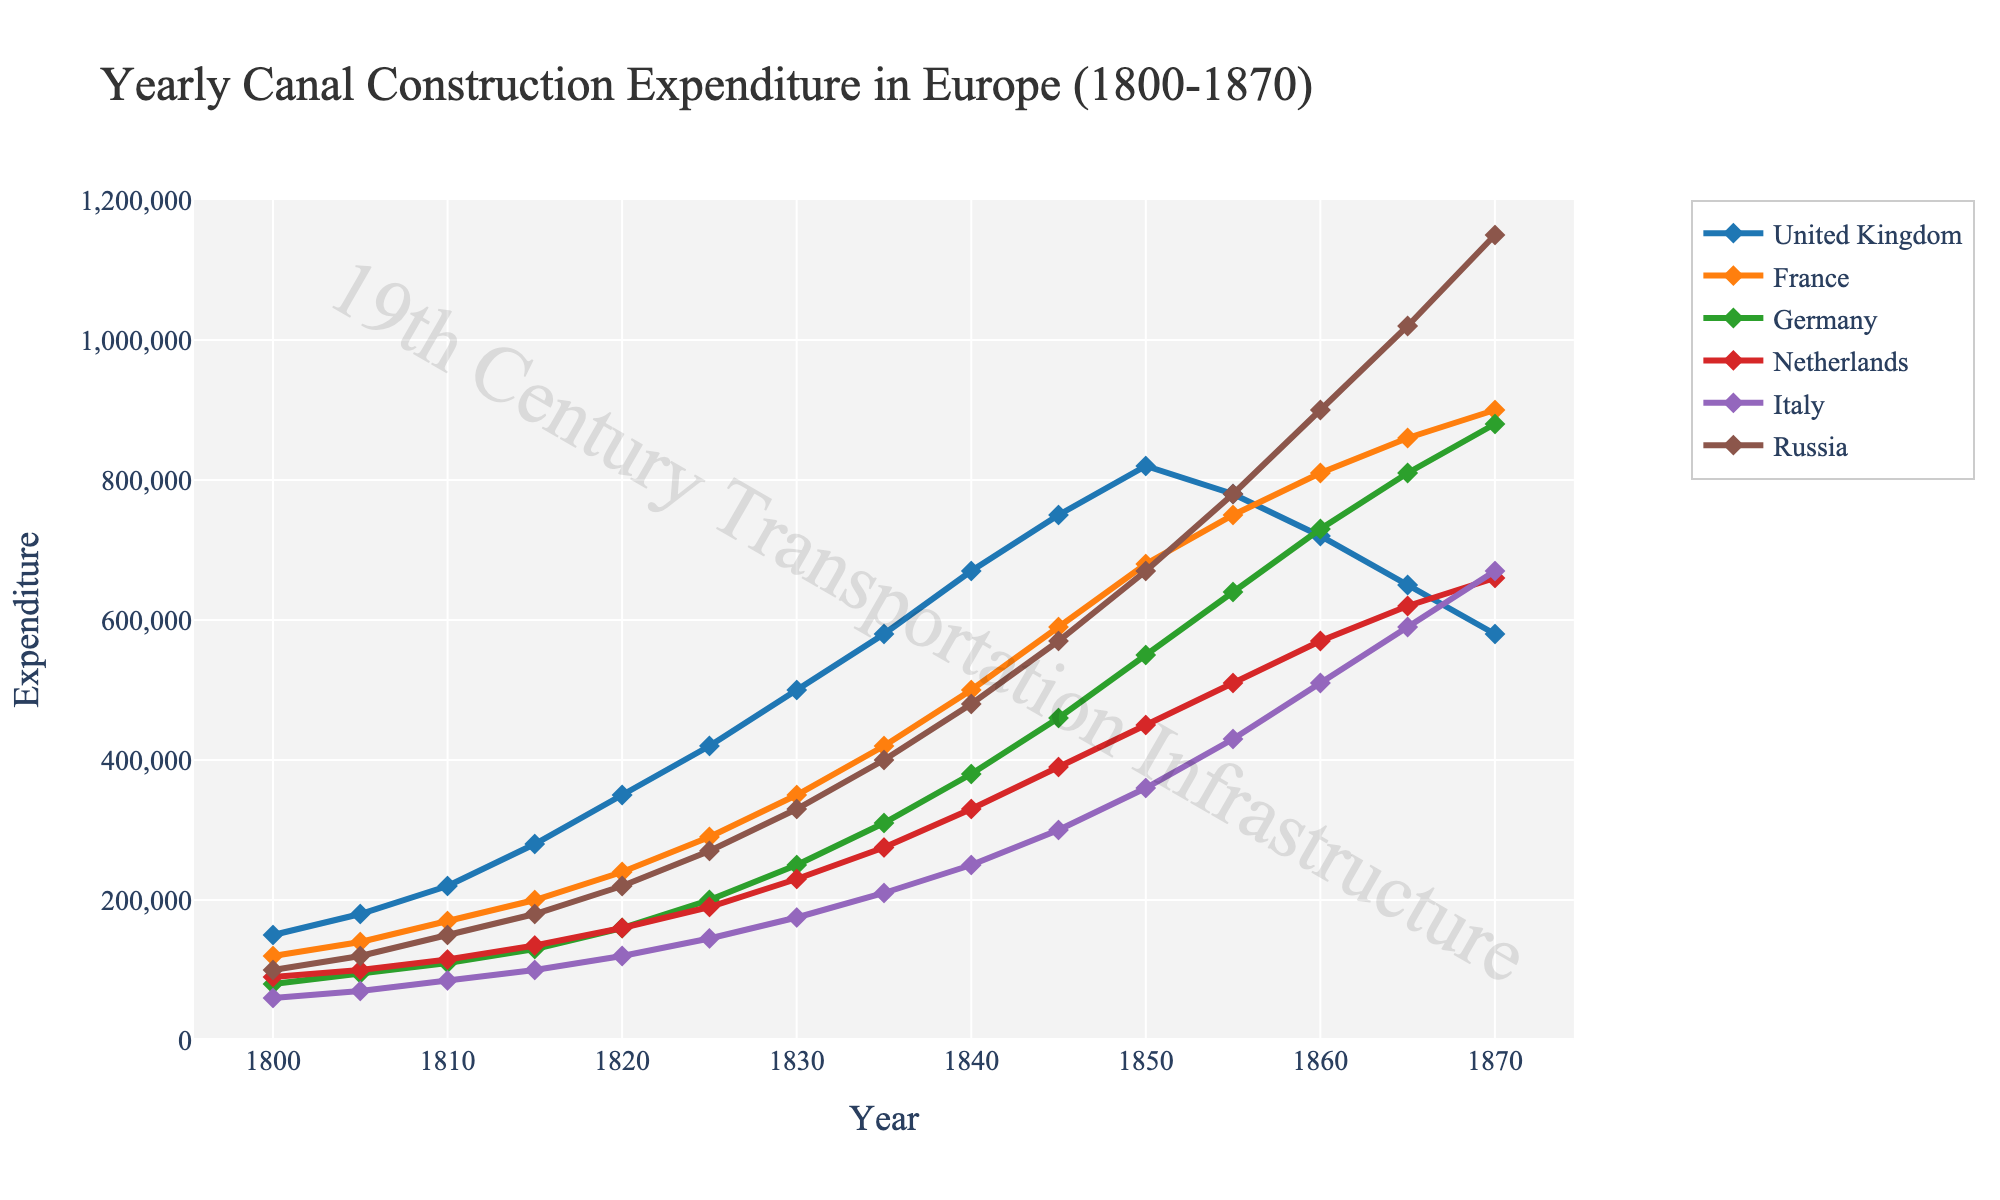what was the expenditure of the United Kingdom and France combined in 1850? To find the combined expenditure of the United Kingdom and France in 1850, sum their individual expenditures. From the data: United Kingdom = 820,000 and France = 680,000. Combined expenditure = 820,000 + 680,000.
Answer: 1,500,000 Which country had the highest canal construction expenditure in 1830? Compare the expenditures of all the countries in 1830. The expenditures are: United Kingdom = 500,000, France = 350,000, Germany = 250,000, Netherlands = 230,000, Italy = 175,000, Russia = 330,000. The United Kingdom has the highest expenditure.
Answer: United Kingdom Between 1840 and 1850, which country showed the greatest increase in canal construction expenditure? Calculate the difference in expenditure for each country between 1840 and 1850: United Kingdom = 820,000 - 670,000 = 150,000, France = 680,000 - 500,000 = 180,000, Germany = 550,000 - 380,000 = 170,000, Netherlands = 450,000 - 330,000 = 120,000, Italy = 360,000 - 250,000 = 110,000, Russia = 670,000 - 480,000 = 190,000. Russia showed the greatest increase.
Answer: Russia What color represents Germany in the plot? Identify the color used for the line representing Germany. According to the generation code, Germany is assigned the third color which is green.
Answer: Green By how much did the expenditure of Italy change from 1860 to 1870? Subtract the expenditure in 1860 from that in 1870 for Italy. 1870 expenditure = 670,000, 1860 expenditure = 510,000. Change = 670,000 - 510,000.
Answer: 160,000 What trend do you observe in the canal construction expenditure for the Netherlands from 1800 to 1870? Look at the data points over the years for the Netherlands and describe the trend. The expenditure gradually increases from 90,000 in 1800 to 660,000 in 1870, showing a steady increase over the period.
Answer: Steady increase Which countries had a peak in their canal construction expenditure in 1855? Identify the countries from the data whose expenditure is highest around 1855. The expenditures in 1855 were: United Kingdom = 780,000, France = 750,000, Germany = 640,000, Netherlands = 510,000, Italy = 430,000, Russia = 780,000. Comparing these to previous and next years, France and Russia show a peak.
Answer: France, Russia What is the average canal construction expenditure of Russia from 1840 to 1855? Sum the expenditures of Russia from 1840 to 1855 and divide by the number of years. Expenditures are 480,000 + 570,000 + 670,000 + 780,000 + 720,000 = 3,220,000. Number of years = 5. Average expenditure = 3,220,000 / 5.
Answer: 644,000 Compare the expenditure between Germany and Italy in 1870. Which country spent more? Look at the expenditures for Germany and Italy in 1870. Germany = 880,000, Italy = 670,000. Germany spent more than Italy.
Answer: Germany 